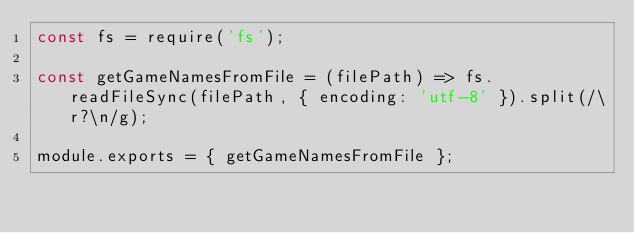Convert code to text. <code><loc_0><loc_0><loc_500><loc_500><_JavaScript_>const fs = require('fs');

const getGameNamesFromFile = (filePath) => fs.readFileSync(filePath, { encoding: 'utf-8' }).split(/\r?\n/g);

module.exports = { getGameNamesFromFile };</code> 